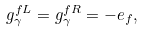Convert formula to latex. <formula><loc_0><loc_0><loc_500><loc_500>g _ { \gamma } ^ { f L } = g _ { \gamma } ^ { f R } = - e _ { f } ,</formula> 